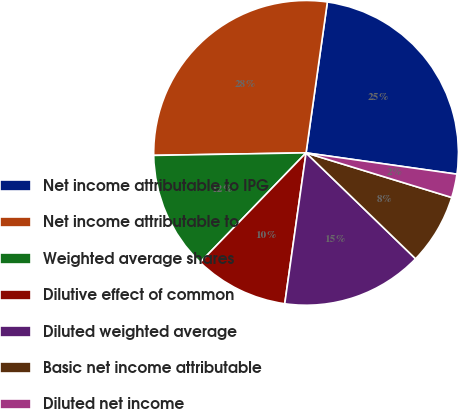Convert chart. <chart><loc_0><loc_0><loc_500><loc_500><pie_chart><fcel>Net income attributable to IPG<fcel>Net income attributable to<fcel>Weighted average shares<fcel>Dilutive effect of common<fcel>Diluted weighted average<fcel>Basic net income attributable<fcel>Diluted net income<nl><fcel>25.0%<fcel>27.5%<fcel>12.5%<fcel>10.0%<fcel>15.0%<fcel>7.5%<fcel>2.5%<nl></chart> 